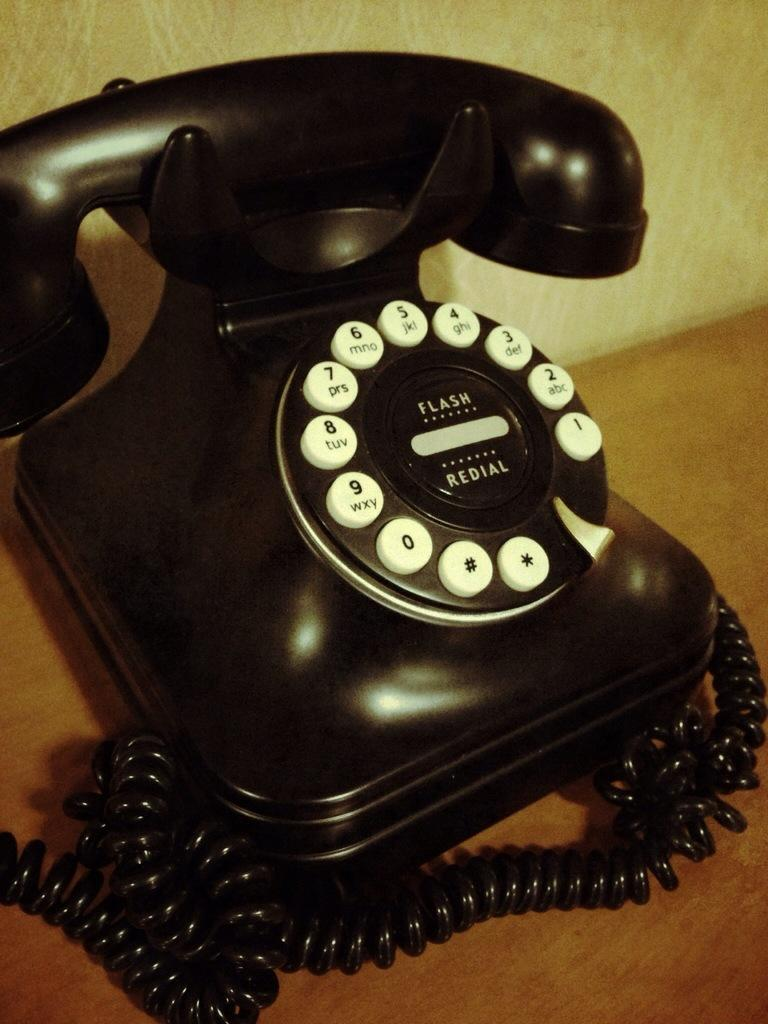What object is present in the image that is used for communication? There is a telephone in the image that is used for communication. What is the color of the telephone? The telephone is black in color. What feature of the telephone is used for dialing numbers? There are numbers on the telephone that are used for dialing. How is the telephone connected to a power source or network? There is a cable wire associated with the telephone for connectivity. What type of surface is visible in the image? There is a wooden surface in the image. What type of crate is visible in the image, and how does it relate to the telephone? There is no crate present in the image, and therefore it cannot be related to the telephone. 